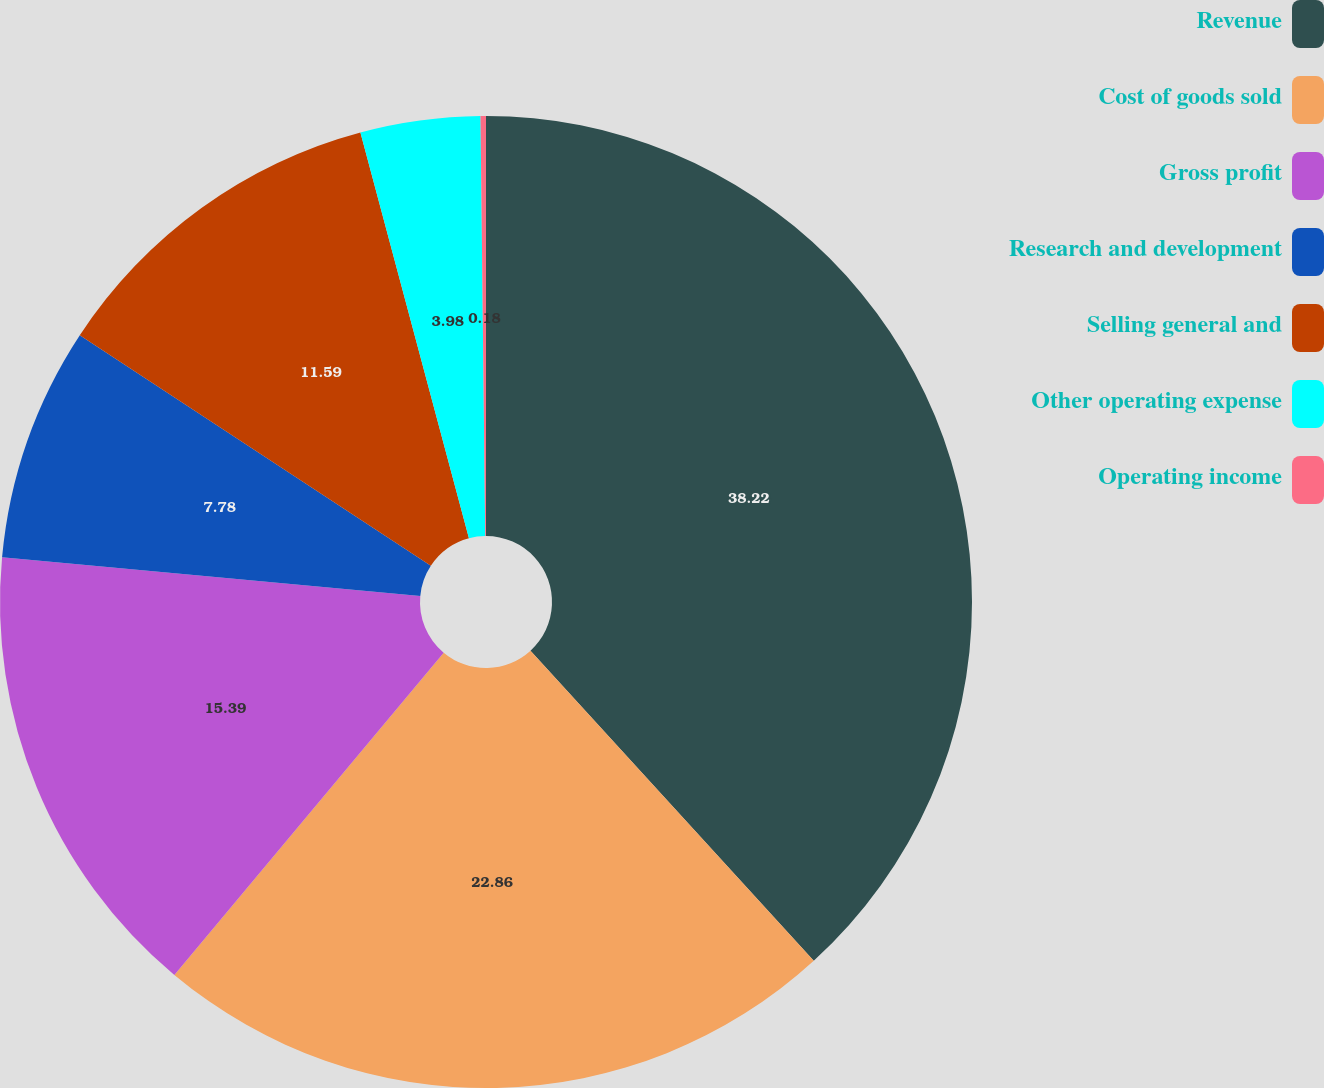Convert chart. <chart><loc_0><loc_0><loc_500><loc_500><pie_chart><fcel>Revenue<fcel>Cost of goods sold<fcel>Gross profit<fcel>Research and development<fcel>Selling general and<fcel>Other operating expense<fcel>Operating income<nl><fcel>38.22%<fcel>22.86%<fcel>15.39%<fcel>7.78%<fcel>11.59%<fcel>3.98%<fcel>0.18%<nl></chart> 